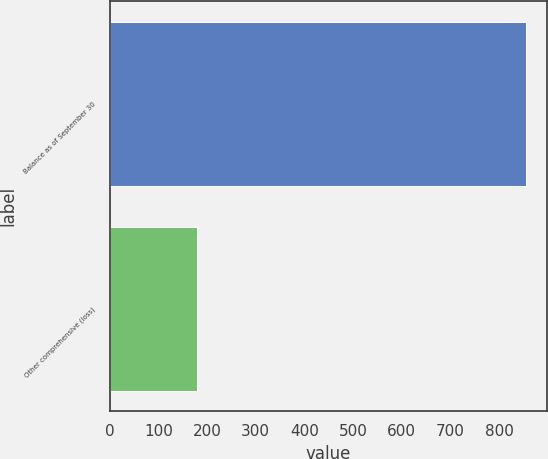Convert chart to OTSL. <chart><loc_0><loc_0><loc_500><loc_500><bar_chart><fcel>Balance as of September 30<fcel>Other comprehensive (loss)<nl><fcel>854.9<fcel>178.7<nl></chart> 